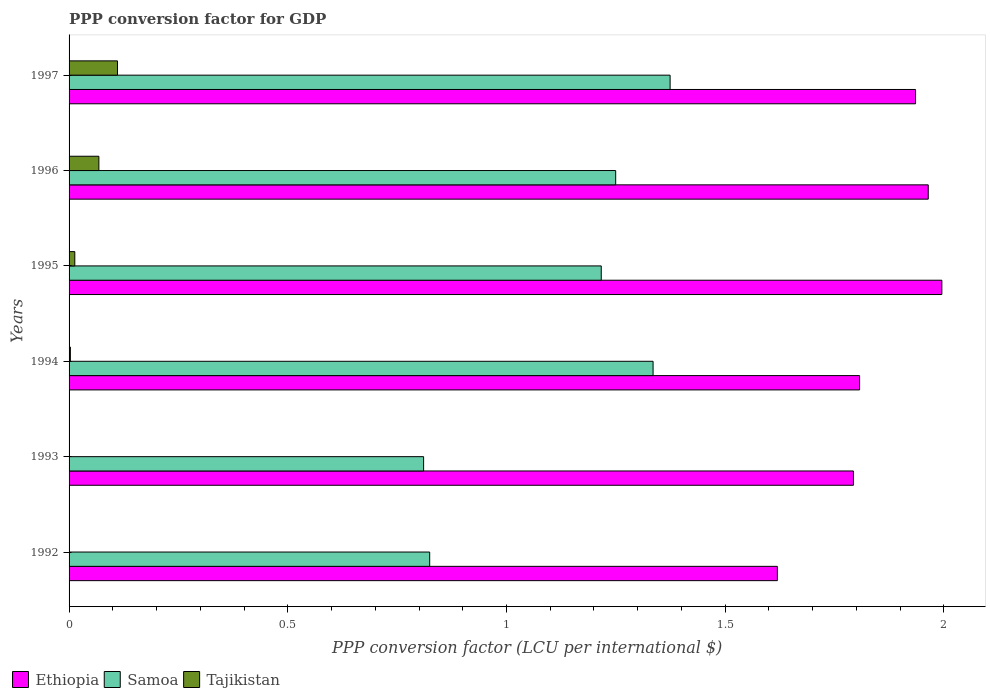Are the number of bars on each tick of the Y-axis equal?
Ensure brevity in your answer.  Yes. What is the PPP conversion factor for GDP in Ethiopia in 1996?
Offer a very short reply. 1.96. Across all years, what is the maximum PPP conversion factor for GDP in Samoa?
Offer a terse response. 1.37. Across all years, what is the minimum PPP conversion factor for GDP in Tajikistan?
Offer a terse response. 7.45704164810197e-5. What is the total PPP conversion factor for GDP in Tajikistan in the graph?
Your answer should be compact. 0.2. What is the difference between the PPP conversion factor for GDP in Ethiopia in 1994 and that in 1995?
Keep it short and to the point. -0.19. What is the difference between the PPP conversion factor for GDP in Ethiopia in 1993 and the PPP conversion factor for GDP in Samoa in 1994?
Offer a very short reply. 0.46. What is the average PPP conversion factor for GDP in Tajikistan per year?
Provide a short and direct response. 0.03. In the year 1997, what is the difference between the PPP conversion factor for GDP in Ethiopia and PPP conversion factor for GDP in Samoa?
Your answer should be compact. 0.56. In how many years, is the PPP conversion factor for GDP in Samoa greater than 1.8 LCU?
Provide a succinct answer. 0. What is the ratio of the PPP conversion factor for GDP in Tajikistan in 1993 to that in 1994?
Your answer should be very brief. 0.32. Is the difference between the PPP conversion factor for GDP in Ethiopia in 1995 and 1996 greater than the difference between the PPP conversion factor for GDP in Samoa in 1995 and 1996?
Make the answer very short. Yes. What is the difference between the highest and the second highest PPP conversion factor for GDP in Ethiopia?
Your answer should be very brief. 0.03. What is the difference between the highest and the lowest PPP conversion factor for GDP in Tajikistan?
Provide a short and direct response. 0.11. In how many years, is the PPP conversion factor for GDP in Tajikistan greater than the average PPP conversion factor for GDP in Tajikistan taken over all years?
Ensure brevity in your answer.  2. Is the sum of the PPP conversion factor for GDP in Samoa in 1993 and 1995 greater than the maximum PPP conversion factor for GDP in Ethiopia across all years?
Keep it short and to the point. Yes. What does the 3rd bar from the top in 1993 represents?
Offer a terse response. Ethiopia. What does the 3rd bar from the bottom in 1994 represents?
Provide a succinct answer. Tajikistan. Is it the case that in every year, the sum of the PPP conversion factor for GDP in Ethiopia and PPP conversion factor for GDP in Tajikistan is greater than the PPP conversion factor for GDP in Samoa?
Offer a terse response. Yes. How many bars are there?
Keep it short and to the point. 18. How many years are there in the graph?
Offer a very short reply. 6. Are the values on the major ticks of X-axis written in scientific E-notation?
Provide a short and direct response. No. Does the graph contain grids?
Your answer should be compact. No. How many legend labels are there?
Your answer should be compact. 3. How are the legend labels stacked?
Your answer should be compact. Horizontal. What is the title of the graph?
Your answer should be very brief. PPP conversion factor for GDP. Does "Tunisia" appear as one of the legend labels in the graph?
Provide a succinct answer. No. What is the label or title of the X-axis?
Make the answer very short. PPP conversion factor (LCU per international $). What is the PPP conversion factor (LCU per international $) in Ethiopia in 1992?
Offer a terse response. 1.62. What is the PPP conversion factor (LCU per international $) of Samoa in 1992?
Ensure brevity in your answer.  0.82. What is the PPP conversion factor (LCU per international $) of Tajikistan in 1992?
Make the answer very short. 7.45704164810197e-5. What is the PPP conversion factor (LCU per international $) in Ethiopia in 1993?
Provide a short and direct response. 1.79. What is the PPP conversion factor (LCU per international $) in Samoa in 1993?
Provide a succinct answer. 0.81. What is the PPP conversion factor (LCU per international $) in Tajikistan in 1993?
Ensure brevity in your answer.  0. What is the PPP conversion factor (LCU per international $) in Ethiopia in 1994?
Your answer should be compact. 1.81. What is the PPP conversion factor (LCU per international $) of Samoa in 1994?
Your response must be concise. 1.34. What is the PPP conversion factor (LCU per international $) of Tajikistan in 1994?
Keep it short and to the point. 0. What is the PPP conversion factor (LCU per international $) of Ethiopia in 1995?
Your answer should be very brief. 2. What is the PPP conversion factor (LCU per international $) of Samoa in 1995?
Make the answer very short. 1.22. What is the PPP conversion factor (LCU per international $) of Tajikistan in 1995?
Your answer should be compact. 0.01. What is the PPP conversion factor (LCU per international $) in Ethiopia in 1996?
Ensure brevity in your answer.  1.96. What is the PPP conversion factor (LCU per international $) in Samoa in 1996?
Your answer should be very brief. 1.25. What is the PPP conversion factor (LCU per international $) of Tajikistan in 1996?
Give a very brief answer. 0.07. What is the PPP conversion factor (LCU per international $) of Ethiopia in 1997?
Your response must be concise. 1.94. What is the PPP conversion factor (LCU per international $) in Samoa in 1997?
Your answer should be very brief. 1.37. What is the PPP conversion factor (LCU per international $) in Tajikistan in 1997?
Make the answer very short. 0.11. Across all years, what is the maximum PPP conversion factor (LCU per international $) in Ethiopia?
Offer a terse response. 2. Across all years, what is the maximum PPP conversion factor (LCU per international $) of Samoa?
Your response must be concise. 1.37. Across all years, what is the maximum PPP conversion factor (LCU per international $) of Tajikistan?
Your response must be concise. 0.11. Across all years, what is the minimum PPP conversion factor (LCU per international $) of Ethiopia?
Offer a terse response. 1.62. Across all years, what is the minimum PPP conversion factor (LCU per international $) of Samoa?
Your answer should be compact. 0.81. Across all years, what is the minimum PPP conversion factor (LCU per international $) of Tajikistan?
Offer a terse response. 7.45704164810197e-5. What is the total PPP conversion factor (LCU per international $) in Ethiopia in the graph?
Make the answer very short. 11.11. What is the total PPP conversion factor (LCU per international $) of Samoa in the graph?
Your answer should be very brief. 6.81. What is the total PPP conversion factor (LCU per international $) of Tajikistan in the graph?
Provide a succinct answer. 0.2. What is the difference between the PPP conversion factor (LCU per international $) of Ethiopia in 1992 and that in 1993?
Provide a short and direct response. -0.17. What is the difference between the PPP conversion factor (LCU per international $) in Samoa in 1992 and that in 1993?
Ensure brevity in your answer.  0.01. What is the difference between the PPP conversion factor (LCU per international $) of Tajikistan in 1992 and that in 1993?
Your answer should be very brief. -0. What is the difference between the PPP conversion factor (LCU per international $) of Ethiopia in 1992 and that in 1994?
Provide a short and direct response. -0.19. What is the difference between the PPP conversion factor (LCU per international $) in Samoa in 1992 and that in 1994?
Provide a short and direct response. -0.51. What is the difference between the PPP conversion factor (LCU per international $) in Tajikistan in 1992 and that in 1994?
Your answer should be compact. -0. What is the difference between the PPP conversion factor (LCU per international $) in Ethiopia in 1992 and that in 1995?
Offer a very short reply. -0.38. What is the difference between the PPP conversion factor (LCU per international $) in Samoa in 1992 and that in 1995?
Keep it short and to the point. -0.39. What is the difference between the PPP conversion factor (LCU per international $) of Tajikistan in 1992 and that in 1995?
Ensure brevity in your answer.  -0.01. What is the difference between the PPP conversion factor (LCU per international $) of Ethiopia in 1992 and that in 1996?
Provide a succinct answer. -0.34. What is the difference between the PPP conversion factor (LCU per international $) of Samoa in 1992 and that in 1996?
Offer a terse response. -0.43. What is the difference between the PPP conversion factor (LCU per international $) in Tajikistan in 1992 and that in 1996?
Ensure brevity in your answer.  -0.07. What is the difference between the PPP conversion factor (LCU per international $) of Ethiopia in 1992 and that in 1997?
Keep it short and to the point. -0.32. What is the difference between the PPP conversion factor (LCU per international $) in Samoa in 1992 and that in 1997?
Keep it short and to the point. -0.55. What is the difference between the PPP conversion factor (LCU per international $) in Tajikistan in 1992 and that in 1997?
Your response must be concise. -0.11. What is the difference between the PPP conversion factor (LCU per international $) of Ethiopia in 1993 and that in 1994?
Your answer should be compact. -0.01. What is the difference between the PPP conversion factor (LCU per international $) in Samoa in 1993 and that in 1994?
Offer a very short reply. -0.52. What is the difference between the PPP conversion factor (LCU per international $) of Tajikistan in 1993 and that in 1994?
Ensure brevity in your answer.  -0. What is the difference between the PPP conversion factor (LCU per international $) in Ethiopia in 1993 and that in 1995?
Keep it short and to the point. -0.2. What is the difference between the PPP conversion factor (LCU per international $) of Samoa in 1993 and that in 1995?
Provide a short and direct response. -0.41. What is the difference between the PPP conversion factor (LCU per international $) in Tajikistan in 1993 and that in 1995?
Keep it short and to the point. -0.01. What is the difference between the PPP conversion factor (LCU per international $) in Ethiopia in 1993 and that in 1996?
Ensure brevity in your answer.  -0.17. What is the difference between the PPP conversion factor (LCU per international $) of Samoa in 1993 and that in 1996?
Ensure brevity in your answer.  -0.44. What is the difference between the PPP conversion factor (LCU per international $) of Tajikistan in 1993 and that in 1996?
Give a very brief answer. -0.07. What is the difference between the PPP conversion factor (LCU per international $) in Ethiopia in 1993 and that in 1997?
Offer a terse response. -0.14. What is the difference between the PPP conversion factor (LCU per international $) of Samoa in 1993 and that in 1997?
Provide a short and direct response. -0.56. What is the difference between the PPP conversion factor (LCU per international $) in Tajikistan in 1993 and that in 1997?
Make the answer very short. -0.11. What is the difference between the PPP conversion factor (LCU per international $) in Ethiopia in 1994 and that in 1995?
Your response must be concise. -0.19. What is the difference between the PPP conversion factor (LCU per international $) of Samoa in 1994 and that in 1995?
Provide a succinct answer. 0.12. What is the difference between the PPP conversion factor (LCU per international $) in Tajikistan in 1994 and that in 1995?
Your answer should be very brief. -0.01. What is the difference between the PPP conversion factor (LCU per international $) of Ethiopia in 1994 and that in 1996?
Keep it short and to the point. -0.16. What is the difference between the PPP conversion factor (LCU per international $) of Samoa in 1994 and that in 1996?
Offer a very short reply. 0.09. What is the difference between the PPP conversion factor (LCU per international $) in Tajikistan in 1994 and that in 1996?
Keep it short and to the point. -0.07. What is the difference between the PPP conversion factor (LCU per international $) in Ethiopia in 1994 and that in 1997?
Keep it short and to the point. -0.13. What is the difference between the PPP conversion factor (LCU per international $) in Samoa in 1994 and that in 1997?
Give a very brief answer. -0.04. What is the difference between the PPP conversion factor (LCU per international $) in Tajikistan in 1994 and that in 1997?
Provide a succinct answer. -0.11. What is the difference between the PPP conversion factor (LCU per international $) of Ethiopia in 1995 and that in 1996?
Offer a very short reply. 0.03. What is the difference between the PPP conversion factor (LCU per international $) in Samoa in 1995 and that in 1996?
Offer a terse response. -0.03. What is the difference between the PPP conversion factor (LCU per international $) of Tajikistan in 1995 and that in 1996?
Provide a short and direct response. -0.06. What is the difference between the PPP conversion factor (LCU per international $) of Ethiopia in 1995 and that in 1997?
Your answer should be compact. 0.06. What is the difference between the PPP conversion factor (LCU per international $) of Samoa in 1995 and that in 1997?
Make the answer very short. -0.16. What is the difference between the PPP conversion factor (LCU per international $) of Tajikistan in 1995 and that in 1997?
Offer a very short reply. -0.1. What is the difference between the PPP conversion factor (LCU per international $) in Ethiopia in 1996 and that in 1997?
Keep it short and to the point. 0.03. What is the difference between the PPP conversion factor (LCU per international $) of Samoa in 1996 and that in 1997?
Offer a very short reply. -0.12. What is the difference between the PPP conversion factor (LCU per international $) in Tajikistan in 1996 and that in 1997?
Provide a succinct answer. -0.04. What is the difference between the PPP conversion factor (LCU per international $) of Ethiopia in 1992 and the PPP conversion factor (LCU per international $) of Samoa in 1993?
Make the answer very short. 0.81. What is the difference between the PPP conversion factor (LCU per international $) in Ethiopia in 1992 and the PPP conversion factor (LCU per international $) in Tajikistan in 1993?
Your answer should be very brief. 1.62. What is the difference between the PPP conversion factor (LCU per international $) in Samoa in 1992 and the PPP conversion factor (LCU per international $) in Tajikistan in 1993?
Keep it short and to the point. 0.82. What is the difference between the PPP conversion factor (LCU per international $) in Ethiopia in 1992 and the PPP conversion factor (LCU per international $) in Samoa in 1994?
Provide a short and direct response. 0.28. What is the difference between the PPP conversion factor (LCU per international $) in Ethiopia in 1992 and the PPP conversion factor (LCU per international $) in Tajikistan in 1994?
Make the answer very short. 1.62. What is the difference between the PPP conversion factor (LCU per international $) of Samoa in 1992 and the PPP conversion factor (LCU per international $) of Tajikistan in 1994?
Your answer should be very brief. 0.82. What is the difference between the PPP conversion factor (LCU per international $) of Ethiopia in 1992 and the PPP conversion factor (LCU per international $) of Samoa in 1995?
Your answer should be compact. 0.4. What is the difference between the PPP conversion factor (LCU per international $) in Ethiopia in 1992 and the PPP conversion factor (LCU per international $) in Tajikistan in 1995?
Provide a short and direct response. 1.61. What is the difference between the PPP conversion factor (LCU per international $) in Samoa in 1992 and the PPP conversion factor (LCU per international $) in Tajikistan in 1995?
Give a very brief answer. 0.81. What is the difference between the PPP conversion factor (LCU per international $) in Ethiopia in 1992 and the PPP conversion factor (LCU per international $) in Samoa in 1996?
Your response must be concise. 0.37. What is the difference between the PPP conversion factor (LCU per international $) of Ethiopia in 1992 and the PPP conversion factor (LCU per international $) of Tajikistan in 1996?
Give a very brief answer. 1.55. What is the difference between the PPP conversion factor (LCU per international $) of Samoa in 1992 and the PPP conversion factor (LCU per international $) of Tajikistan in 1996?
Your response must be concise. 0.76. What is the difference between the PPP conversion factor (LCU per international $) of Ethiopia in 1992 and the PPP conversion factor (LCU per international $) of Samoa in 1997?
Offer a terse response. 0.25. What is the difference between the PPP conversion factor (LCU per international $) in Ethiopia in 1992 and the PPP conversion factor (LCU per international $) in Tajikistan in 1997?
Make the answer very short. 1.51. What is the difference between the PPP conversion factor (LCU per international $) of Samoa in 1992 and the PPP conversion factor (LCU per international $) of Tajikistan in 1997?
Ensure brevity in your answer.  0.71. What is the difference between the PPP conversion factor (LCU per international $) in Ethiopia in 1993 and the PPP conversion factor (LCU per international $) in Samoa in 1994?
Offer a terse response. 0.46. What is the difference between the PPP conversion factor (LCU per international $) of Ethiopia in 1993 and the PPP conversion factor (LCU per international $) of Tajikistan in 1994?
Offer a very short reply. 1.79. What is the difference between the PPP conversion factor (LCU per international $) in Samoa in 1993 and the PPP conversion factor (LCU per international $) in Tajikistan in 1994?
Offer a terse response. 0.81. What is the difference between the PPP conversion factor (LCU per international $) in Ethiopia in 1993 and the PPP conversion factor (LCU per international $) in Samoa in 1995?
Keep it short and to the point. 0.58. What is the difference between the PPP conversion factor (LCU per international $) of Ethiopia in 1993 and the PPP conversion factor (LCU per international $) of Tajikistan in 1995?
Make the answer very short. 1.78. What is the difference between the PPP conversion factor (LCU per international $) in Samoa in 1993 and the PPP conversion factor (LCU per international $) in Tajikistan in 1995?
Give a very brief answer. 0.8. What is the difference between the PPP conversion factor (LCU per international $) of Ethiopia in 1993 and the PPP conversion factor (LCU per international $) of Samoa in 1996?
Your response must be concise. 0.54. What is the difference between the PPP conversion factor (LCU per international $) of Ethiopia in 1993 and the PPP conversion factor (LCU per international $) of Tajikistan in 1996?
Ensure brevity in your answer.  1.73. What is the difference between the PPP conversion factor (LCU per international $) of Samoa in 1993 and the PPP conversion factor (LCU per international $) of Tajikistan in 1996?
Provide a succinct answer. 0.74. What is the difference between the PPP conversion factor (LCU per international $) of Ethiopia in 1993 and the PPP conversion factor (LCU per international $) of Samoa in 1997?
Make the answer very short. 0.42. What is the difference between the PPP conversion factor (LCU per international $) in Ethiopia in 1993 and the PPP conversion factor (LCU per international $) in Tajikistan in 1997?
Provide a short and direct response. 1.68. What is the difference between the PPP conversion factor (LCU per international $) of Samoa in 1993 and the PPP conversion factor (LCU per international $) of Tajikistan in 1997?
Your answer should be compact. 0.7. What is the difference between the PPP conversion factor (LCU per international $) in Ethiopia in 1994 and the PPP conversion factor (LCU per international $) in Samoa in 1995?
Offer a terse response. 0.59. What is the difference between the PPP conversion factor (LCU per international $) of Ethiopia in 1994 and the PPP conversion factor (LCU per international $) of Tajikistan in 1995?
Provide a succinct answer. 1.79. What is the difference between the PPP conversion factor (LCU per international $) of Samoa in 1994 and the PPP conversion factor (LCU per international $) of Tajikistan in 1995?
Keep it short and to the point. 1.32. What is the difference between the PPP conversion factor (LCU per international $) of Ethiopia in 1994 and the PPP conversion factor (LCU per international $) of Samoa in 1996?
Offer a very short reply. 0.56. What is the difference between the PPP conversion factor (LCU per international $) of Ethiopia in 1994 and the PPP conversion factor (LCU per international $) of Tajikistan in 1996?
Provide a succinct answer. 1.74. What is the difference between the PPP conversion factor (LCU per international $) of Samoa in 1994 and the PPP conversion factor (LCU per international $) of Tajikistan in 1996?
Provide a short and direct response. 1.27. What is the difference between the PPP conversion factor (LCU per international $) in Ethiopia in 1994 and the PPP conversion factor (LCU per international $) in Samoa in 1997?
Your response must be concise. 0.43. What is the difference between the PPP conversion factor (LCU per international $) of Ethiopia in 1994 and the PPP conversion factor (LCU per international $) of Tajikistan in 1997?
Provide a succinct answer. 1.7. What is the difference between the PPP conversion factor (LCU per international $) of Samoa in 1994 and the PPP conversion factor (LCU per international $) of Tajikistan in 1997?
Your answer should be very brief. 1.22. What is the difference between the PPP conversion factor (LCU per international $) in Ethiopia in 1995 and the PPP conversion factor (LCU per international $) in Samoa in 1996?
Give a very brief answer. 0.75. What is the difference between the PPP conversion factor (LCU per international $) of Ethiopia in 1995 and the PPP conversion factor (LCU per international $) of Tajikistan in 1996?
Provide a succinct answer. 1.93. What is the difference between the PPP conversion factor (LCU per international $) of Samoa in 1995 and the PPP conversion factor (LCU per international $) of Tajikistan in 1996?
Offer a terse response. 1.15. What is the difference between the PPP conversion factor (LCU per international $) of Ethiopia in 1995 and the PPP conversion factor (LCU per international $) of Samoa in 1997?
Ensure brevity in your answer.  0.62. What is the difference between the PPP conversion factor (LCU per international $) in Ethiopia in 1995 and the PPP conversion factor (LCU per international $) in Tajikistan in 1997?
Make the answer very short. 1.88. What is the difference between the PPP conversion factor (LCU per international $) in Samoa in 1995 and the PPP conversion factor (LCU per international $) in Tajikistan in 1997?
Your answer should be compact. 1.11. What is the difference between the PPP conversion factor (LCU per international $) of Ethiopia in 1996 and the PPP conversion factor (LCU per international $) of Samoa in 1997?
Provide a short and direct response. 0.59. What is the difference between the PPP conversion factor (LCU per international $) of Ethiopia in 1996 and the PPP conversion factor (LCU per international $) of Tajikistan in 1997?
Your answer should be very brief. 1.85. What is the difference between the PPP conversion factor (LCU per international $) of Samoa in 1996 and the PPP conversion factor (LCU per international $) of Tajikistan in 1997?
Offer a terse response. 1.14. What is the average PPP conversion factor (LCU per international $) of Ethiopia per year?
Offer a terse response. 1.85. What is the average PPP conversion factor (LCU per international $) in Samoa per year?
Give a very brief answer. 1.14. What is the average PPP conversion factor (LCU per international $) in Tajikistan per year?
Provide a short and direct response. 0.03. In the year 1992, what is the difference between the PPP conversion factor (LCU per international $) in Ethiopia and PPP conversion factor (LCU per international $) in Samoa?
Give a very brief answer. 0.79. In the year 1992, what is the difference between the PPP conversion factor (LCU per international $) in Ethiopia and PPP conversion factor (LCU per international $) in Tajikistan?
Provide a short and direct response. 1.62. In the year 1992, what is the difference between the PPP conversion factor (LCU per international $) in Samoa and PPP conversion factor (LCU per international $) in Tajikistan?
Keep it short and to the point. 0.82. In the year 1993, what is the difference between the PPP conversion factor (LCU per international $) in Ethiopia and PPP conversion factor (LCU per international $) in Samoa?
Offer a very short reply. 0.98. In the year 1993, what is the difference between the PPP conversion factor (LCU per international $) in Ethiopia and PPP conversion factor (LCU per international $) in Tajikistan?
Offer a terse response. 1.79. In the year 1993, what is the difference between the PPP conversion factor (LCU per international $) of Samoa and PPP conversion factor (LCU per international $) of Tajikistan?
Offer a terse response. 0.81. In the year 1994, what is the difference between the PPP conversion factor (LCU per international $) in Ethiopia and PPP conversion factor (LCU per international $) in Samoa?
Ensure brevity in your answer.  0.47. In the year 1994, what is the difference between the PPP conversion factor (LCU per international $) in Ethiopia and PPP conversion factor (LCU per international $) in Tajikistan?
Provide a short and direct response. 1.8. In the year 1994, what is the difference between the PPP conversion factor (LCU per international $) of Samoa and PPP conversion factor (LCU per international $) of Tajikistan?
Keep it short and to the point. 1.33. In the year 1995, what is the difference between the PPP conversion factor (LCU per international $) of Ethiopia and PPP conversion factor (LCU per international $) of Samoa?
Provide a succinct answer. 0.78. In the year 1995, what is the difference between the PPP conversion factor (LCU per international $) of Ethiopia and PPP conversion factor (LCU per international $) of Tajikistan?
Offer a terse response. 1.98. In the year 1995, what is the difference between the PPP conversion factor (LCU per international $) of Samoa and PPP conversion factor (LCU per international $) of Tajikistan?
Your answer should be compact. 1.2. In the year 1996, what is the difference between the PPP conversion factor (LCU per international $) in Ethiopia and PPP conversion factor (LCU per international $) in Samoa?
Your answer should be compact. 0.71. In the year 1996, what is the difference between the PPP conversion factor (LCU per international $) in Ethiopia and PPP conversion factor (LCU per international $) in Tajikistan?
Your answer should be compact. 1.9. In the year 1996, what is the difference between the PPP conversion factor (LCU per international $) in Samoa and PPP conversion factor (LCU per international $) in Tajikistan?
Offer a very short reply. 1.18. In the year 1997, what is the difference between the PPP conversion factor (LCU per international $) of Ethiopia and PPP conversion factor (LCU per international $) of Samoa?
Your response must be concise. 0.56. In the year 1997, what is the difference between the PPP conversion factor (LCU per international $) in Ethiopia and PPP conversion factor (LCU per international $) in Tajikistan?
Provide a succinct answer. 1.82. In the year 1997, what is the difference between the PPP conversion factor (LCU per international $) in Samoa and PPP conversion factor (LCU per international $) in Tajikistan?
Keep it short and to the point. 1.26. What is the ratio of the PPP conversion factor (LCU per international $) of Ethiopia in 1992 to that in 1993?
Provide a short and direct response. 0.9. What is the ratio of the PPP conversion factor (LCU per international $) of Samoa in 1992 to that in 1993?
Your answer should be compact. 1.02. What is the ratio of the PPP conversion factor (LCU per international $) in Tajikistan in 1992 to that in 1993?
Offer a terse response. 0.08. What is the ratio of the PPP conversion factor (LCU per international $) in Ethiopia in 1992 to that in 1994?
Give a very brief answer. 0.9. What is the ratio of the PPP conversion factor (LCU per international $) in Samoa in 1992 to that in 1994?
Make the answer very short. 0.62. What is the ratio of the PPP conversion factor (LCU per international $) in Tajikistan in 1992 to that in 1994?
Provide a short and direct response. 0.02. What is the ratio of the PPP conversion factor (LCU per international $) in Ethiopia in 1992 to that in 1995?
Give a very brief answer. 0.81. What is the ratio of the PPP conversion factor (LCU per international $) of Samoa in 1992 to that in 1995?
Keep it short and to the point. 0.68. What is the ratio of the PPP conversion factor (LCU per international $) of Tajikistan in 1992 to that in 1995?
Offer a terse response. 0.01. What is the ratio of the PPP conversion factor (LCU per international $) in Ethiopia in 1992 to that in 1996?
Offer a terse response. 0.82. What is the ratio of the PPP conversion factor (LCU per international $) in Samoa in 1992 to that in 1996?
Your answer should be very brief. 0.66. What is the ratio of the PPP conversion factor (LCU per international $) of Tajikistan in 1992 to that in 1996?
Your response must be concise. 0. What is the ratio of the PPP conversion factor (LCU per international $) of Ethiopia in 1992 to that in 1997?
Offer a very short reply. 0.84. What is the ratio of the PPP conversion factor (LCU per international $) in Samoa in 1992 to that in 1997?
Make the answer very short. 0.6. What is the ratio of the PPP conversion factor (LCU per international $) in Tajikistan in 1992 to that in 1997?
Provide a short and direct response. 0. What is the ratio of the PPP conversion factor (LCU per international $) in Samoa in 1993 to that in 1994?
Offer a terse response. 0.61. What is the ratio of the PPP conversion factor (LCU per international $) in Tajikistan in 1993 to that in 1994?
Your response must be concise. 0.32. What is the ratio of the PPP conversion factor (LCU per international $) in Ethiopia in 1993 to that in 1995?
Your response must be concise. 0.9. What is the ratio of the PPP conversion factor (LCU per international $) in Samoa in 1993 to that in 1995?
Your answer should be compact. 0.67. What is the ratio of the PPP conversion factor (LCU per international $) of Tajikistan in 1993 to that in 1995?
Provide a succinct answer. 0.07. What is the ratio of the PPP conversion factor (LCU per international $) in Ethiopia in 1993 to that in 1996?
Provide a succinct answer. 0.91. What is the ratio of the PPP conversion factor (LCU per international $) in Samoa in 1993 to that in 1996?
Give a very brief answer. 0.65. What is the ratio of the PPP conversion factor (LCU per international $) of Tajikistan in 1993 to that in 1996?
Keep it short and to the point. 0.01. What is the ratio of the PPP conversion factor (LCU per international $) in Ethiopia in 1993 to that in 1997?
Provide a short and direct response. 0.93. What is the ratio of the PPP conversion factor (LCU per international $) in Samoa in 1993 to that in 1997?
Offer a very short reply. 0.59. What is the ratio of the PPP conversion factor (LCU per international $) in Tajikistan in 1993 to that in 1997?
Provide a short and direct response. 0.01. What is the ratio of the PPP conversion factor (LCU per international $) of Ethiopia in 1994 to that in 1995?
Your response must be concise. 0.91. What is the ratio of the PPP conversion factor (LCU per international $) in Samoa in 1994 to that in 1995?
Offer a terse response. 1.1. What is the ratio of the PPP conversion factor (LCU per international $) in Tajikistan in 1994 to that in 1995?
Provide a short and direct response. 0.23. What is the ratio of the PPP conversion factor (LCU per international $) in Ethiopia in 1994 to that in 1996?
Offer a very short reply. 0.92. What is the ratio of the PPP conversion factor (LCU per international $) in Samoa in 1994 to that in 1996?
Keep it short and to the point. 1.07. What is the ratio of the PPP conversion factor (LCU per international $) in Tajikistan in 1994 to that in 1996?
Ensure brevity in your answer.  0.04. What is the ratio of the PPP conversion factor (LCU per international $) in Ethiopia in 1994 to that in 1997?
Offer a terse response. 0.93. What is the ratio of the PPP conversion factor (LCU per international $) in Samoa in 1994 to that in 1997?
Your answer should be very brief. 0.97. What is the ratio of the PPP conversion factor (LCU per international $) in Tajikistan in 1994 to that in 1997?
Provide a succinct answer. 0.03. What is the ratio of the PPP conversion factor (LCU per international $) in Ethiopia in 1995 to that in 1996?
Offer a terse response. 1.02. What is the ratio of the PPP conversion factor (LCU per international $) of Samoa in 1995 to that in 1996?
Your response must be concise. 0.97. What is the ratio of the PPP conversion factor (LCU per international $) in Tajikistan in 1995 to that in 1996?
Your response must be concise. 0.19. What is the ratio of the PPP conversion factor (LCU per international $) in Ethiopia in 1995 to that in 1997?
Provide a short and direct response. 1.03. What is the ratio of the PPP conversion factor (LCU per international $) of Samoa in 1995 to that in 1997?
Give a very brief answer. 0.89. What is the ratio of the PPP conversion factor (LCU per international $) of Tajikistan in 1995 to that in 1997?
Offer a terse response. 0.12. What is the ratio of the PPP conversion factor (LCU per international $) in Samoa in 1996 to that in 1997?
Make the answer very short. 0.91. What is the ratio of the PPP conversion factor (LCU per international $) of Tajikistan in 1996 to that in 1997?
Offer a very short reply. 0.62. What is the difference between the highest and the second highest PPP conversion factor (LCU per international $) in Ethiopia?
Offer a very short reply. 0.03. What is the difference between the highest and the second highest PPP conversion factor (LCU per international $) of Samoa?
Provide a succinct answer. 0.04. What is the difference between the highest and the second highest PPP conversion factor (LCU per international $) of Tajikistan?
Your response must be concise. 0.04. What is the difference between the highest and the lowest PPP conversion factor (LCU per international $) of Ethiopia?
Offer a very short reply. 0.38. What is the difference between the highest and the lowest PPP conversion factor (LCU per international $) of Samoa?
Keep it short and to the point. 0.56. What is the difference between the highest and the lowest PPP conversion factor (LCU per international $) in Tajikistan?
Keep it short and to the point. 0.11. 